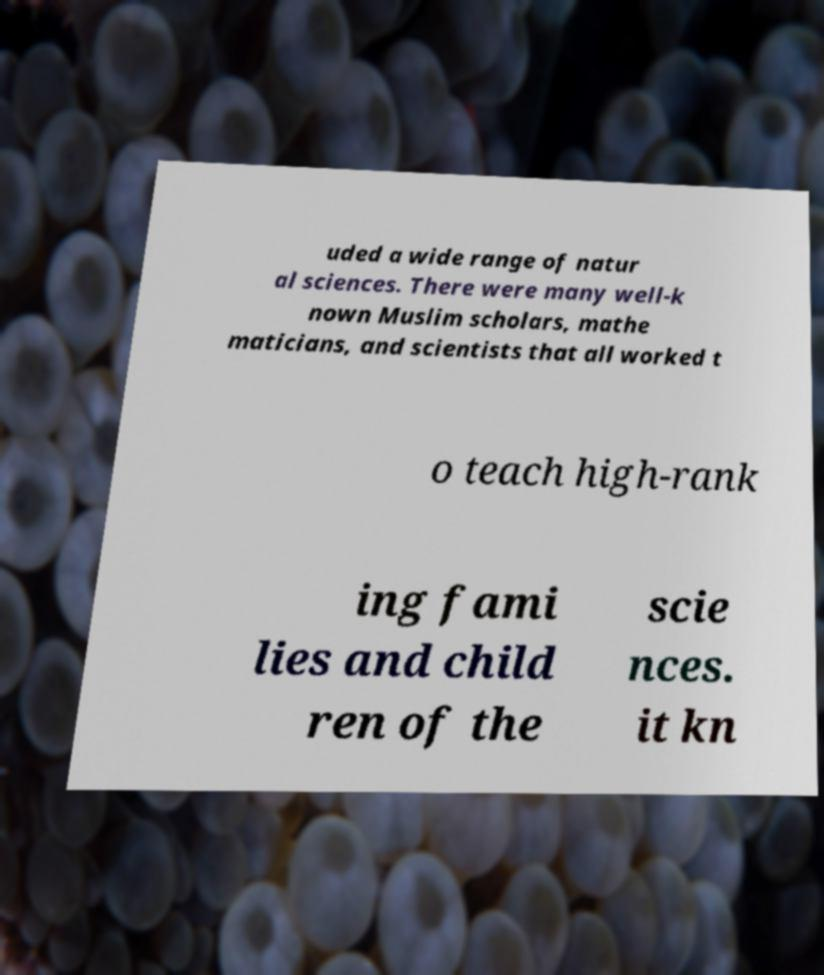What messages or text are displayed in this image? I need them in a readable, typed format. uded a wide range of natur al sciences. There were many well-k nown Muslim scholars, mathe maticians, and scientists that all worked t o teach high-rank ing fami lies and child ren of the scie nces. it kn 